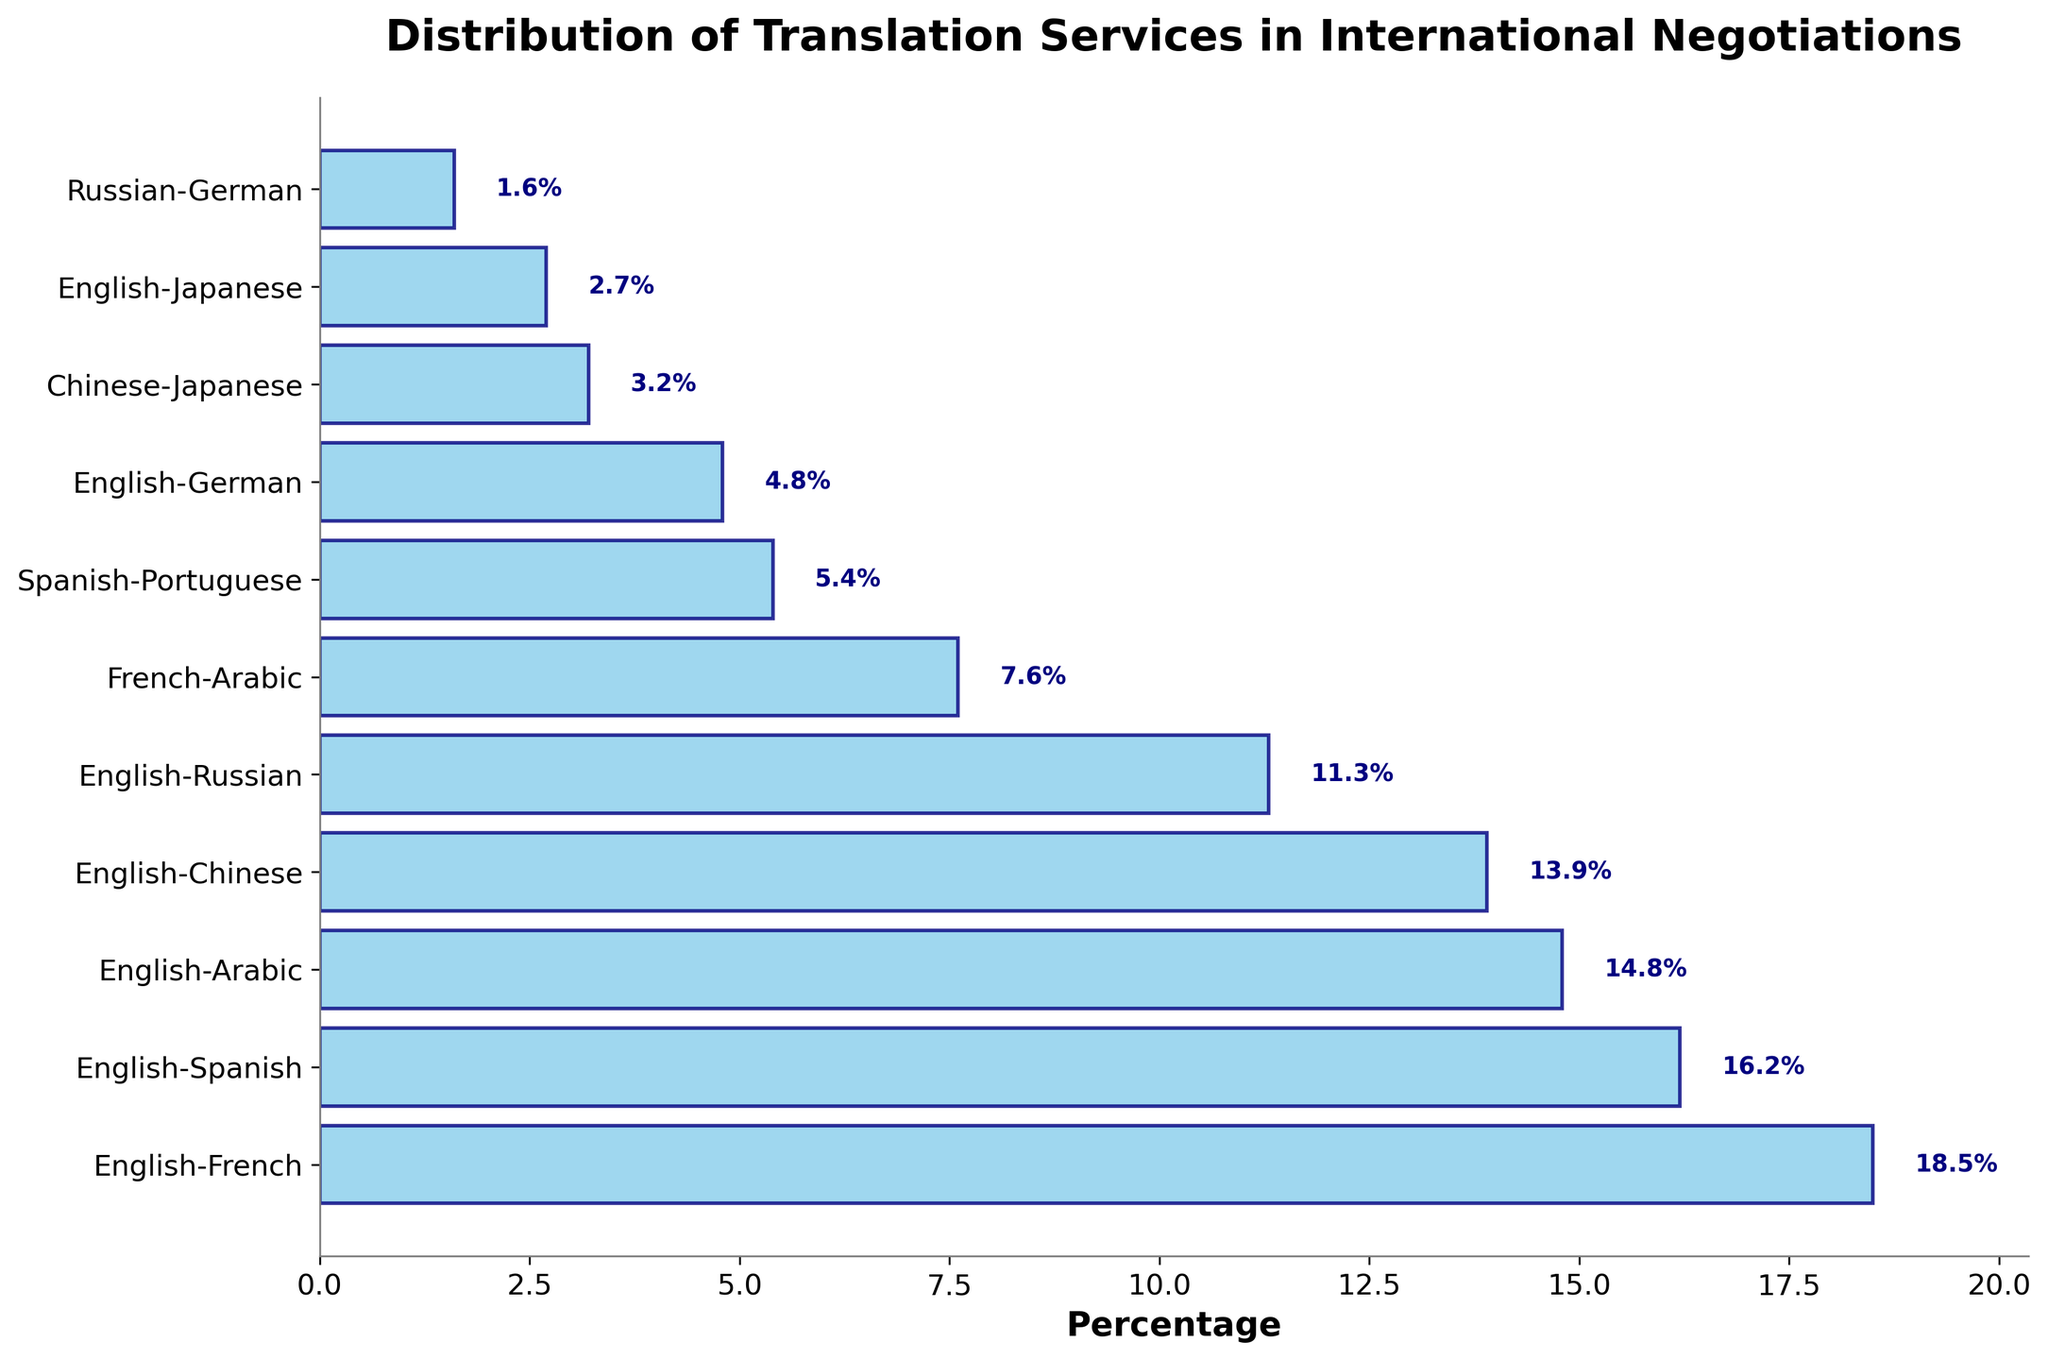What is the percentage of translation services used for the English-French language pair? The English-French bar shows a percentage value at the end of 18.5%.
Answer: 18.5% Which two language pairs have the closest percentage values, and what are those values? By visually comparing the lengths of the bars, the English-Arabic and English-Chinese language pairs have very close percentage values of 14.8% and 13.9%, respectively.
Answer: English-Arabic (14.8%) and English-Chinese (13.9%) What is the total percentage of translation services accounted for by English-French, English-Spanish, and English-Arabic language pairs? Sum the percentages of the English-French (18.5%), English-Spanish (16.2%), and English-Arabic (14.8%) language pairs: 18.5 + 16.2 + 14.8 = 49.5%
Answer: 49.5% Which language pair has the lowest usage of translation services and what is its percentage? The shortest bar corresponds to the Russian-German language pair, with a percentage of 1.6%.
Answer: Russian-German, 1.6% Are there more translation services used for English-German or Chinese-Japanese, and by how much? The English-German percentage is 4.8%, and the Chinese-Japanese percentage is 3.2%. The difference is 4.8 - 3.2 = 1.6%.
Answer: English-German by 1.6% What is the combined percentage for all language pairs that involve French? Adding the percentages for English-French (18.5%) and French-Arabic (7.6%): 18.5 + 7.6 = 26.1%
Answer: 26.1% How much more frequent are English-French translation services compared to English-Japanese? The percentage for English-French is 18.5%, and for English-Japanese, it is 2.7%. The difference is 18.5 - 2.7 = 15.8%.
Answer: 15.8% Which language pair has the third highest usage, and what is its percentage? Ordering the bars by length, the third highest is English-Arabic with 14.8%.
Answer: English-Arabic, 14.8% What is the average percentage of translation services used for the top four language pairs? Sum the percentages for the top four language pairs: 18.5 (English-French) + 16.2 (English-Spanish) + 14.8 (English-Arabic) + 13.9 (English-Chinese) = 63.4. Now, divide by 4: 63.4 / 4 = 15.85%.
Answer: 15.85% Which has a higher combined percentage: English-German + English-Japanese or Spanish-Portuguese? The sum of English-German (4.8%) and English-Japanese (2.7%) is 4.8 + 2.7 = 7.5%. The percentage for Spanish-Portuguese is 5.4%, so English-German + English-Japanese is higher.
Answer: English-German + English-Japanese 